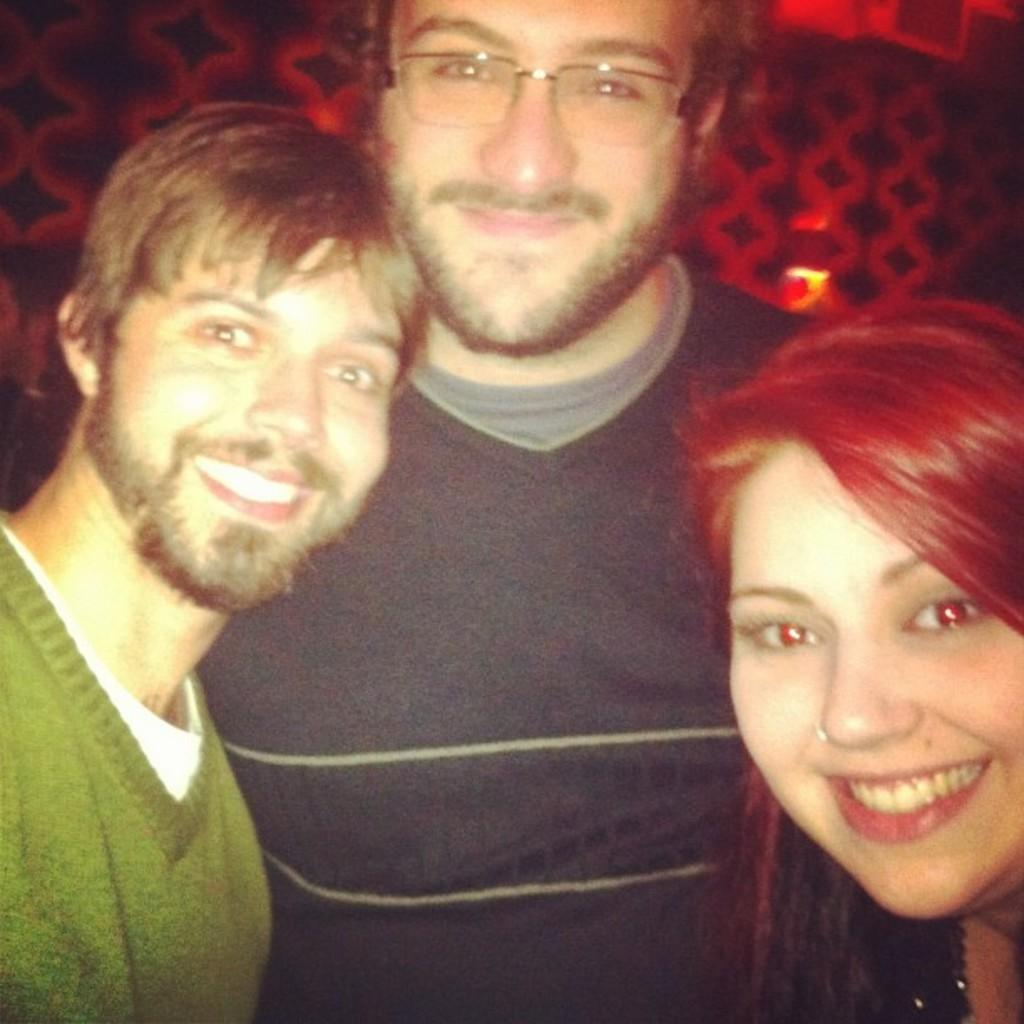How many people are in the image? There are three persons in the image. Where are the people located in the image? The three persons are in the center of the image. What type of insect can be seen flying around the persons in the image? There are no insects visible in the image; it only features three persons. What type of insurance policy do the persons in the image have? There is no information about insurance policies in the image; it only shows three persons. 